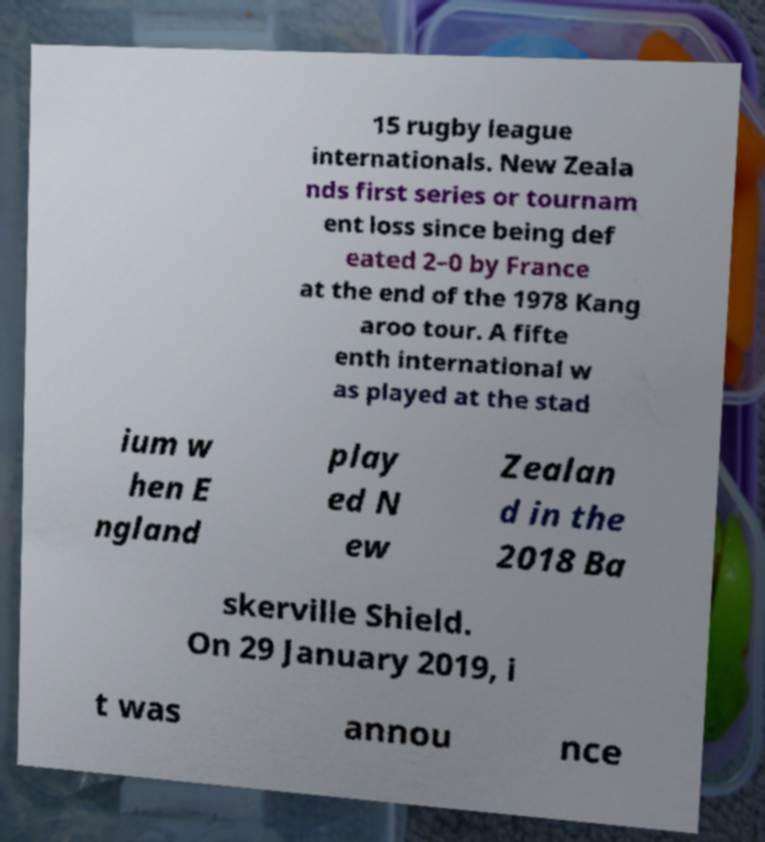Could you assist in decoding the text presented in this image and type it out clearly? 15 rugby league internationals. New Zeala nds first series or tournam ent loss since being def eated 2–0 by France at the end of the 1978 Kang aroo tour. A fifte enth international w as played at the stad ium w hen E ngland play ed N ew Zealan d in the 2018 Ba skerville Shield. On 29 January 2019, i t was annou nce 